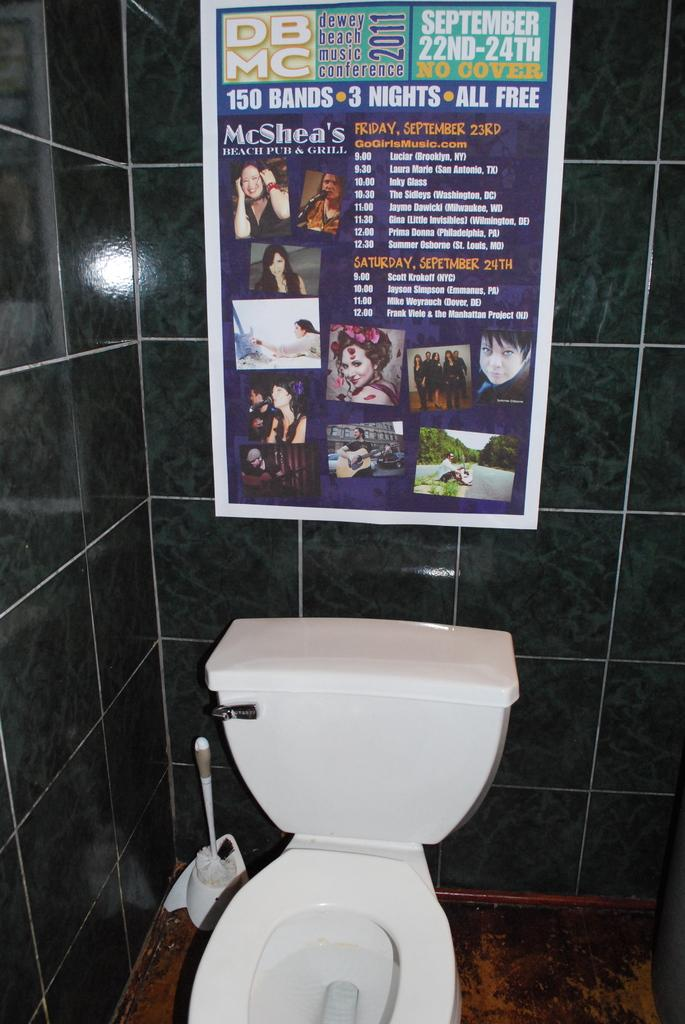What type of fixture is present in the image? There is a commode in the image. What is the purpose of the tank attached to the commode? The tank is a flush tank, used for flushing the commode. What color are the commode and flush tank? The commode and flush tank are white in color. What can be seen on the wall in the image? There is a poster attached to the wall in the image. What object is on the floor near the commode? There is a brush on the floor in the image. What type of support can be seen in the image? There is no specific support structure visible in the image; it primarily features a commode, flush tank, poster, and brush. 